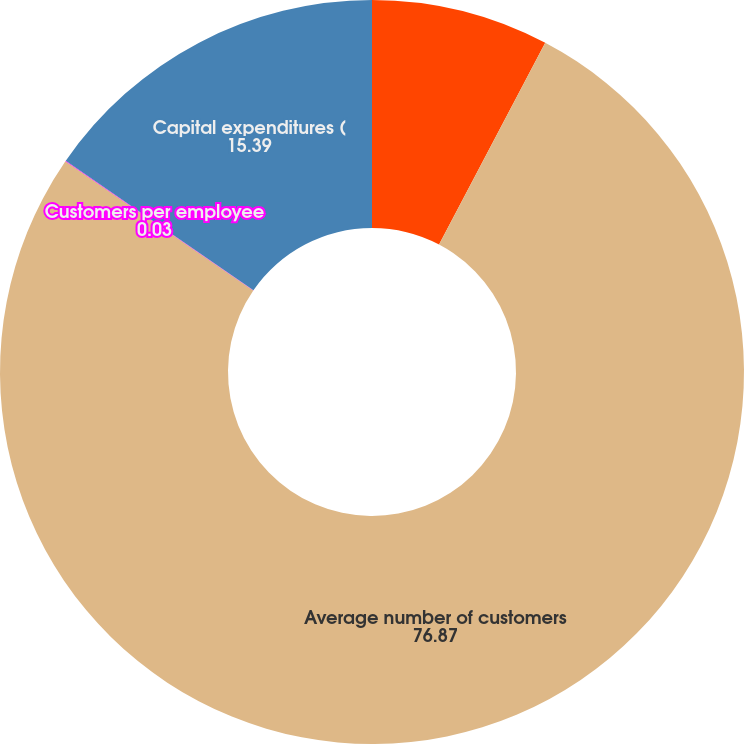Convert chart. <chart><loc_0><loc_0><loc_500><loc_500><pie_chart><fcel>Operating Information<fcel>Average number of customers<fcel>Customers per employee<fcel>Capital expenditures (<nl><fcel>7.71%<fcel>76.87%<fcel>0.03%<fcel>15.39%<nl></chart> 